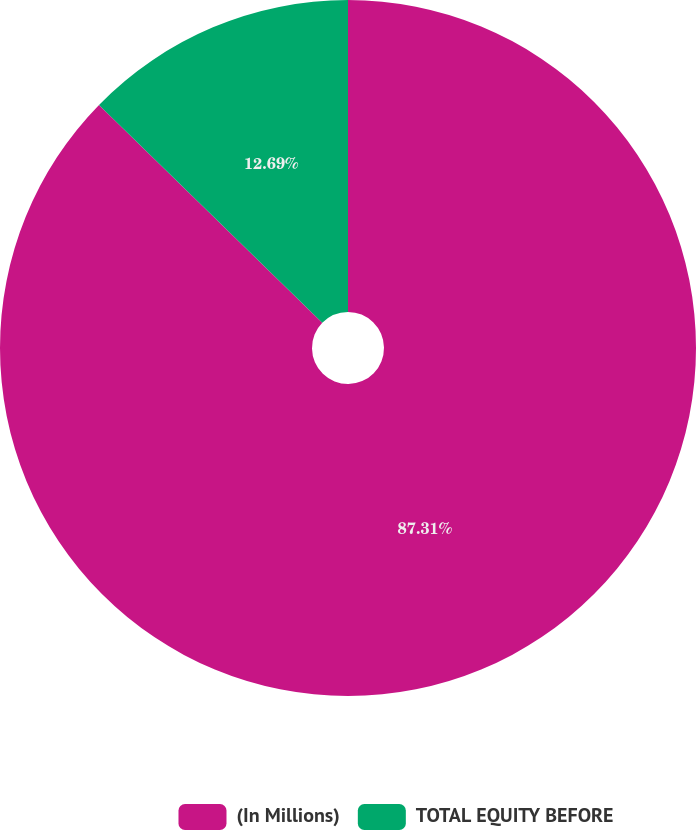Convert chart. <chart><loc_0><loc_0><loc_500><loc_500><pie_chart><fcel>(In Millions)<fcel>TOTAL EQUITY BEFORE<nl><fcel>87.31%<fcel>12.69%<nl></chart> 